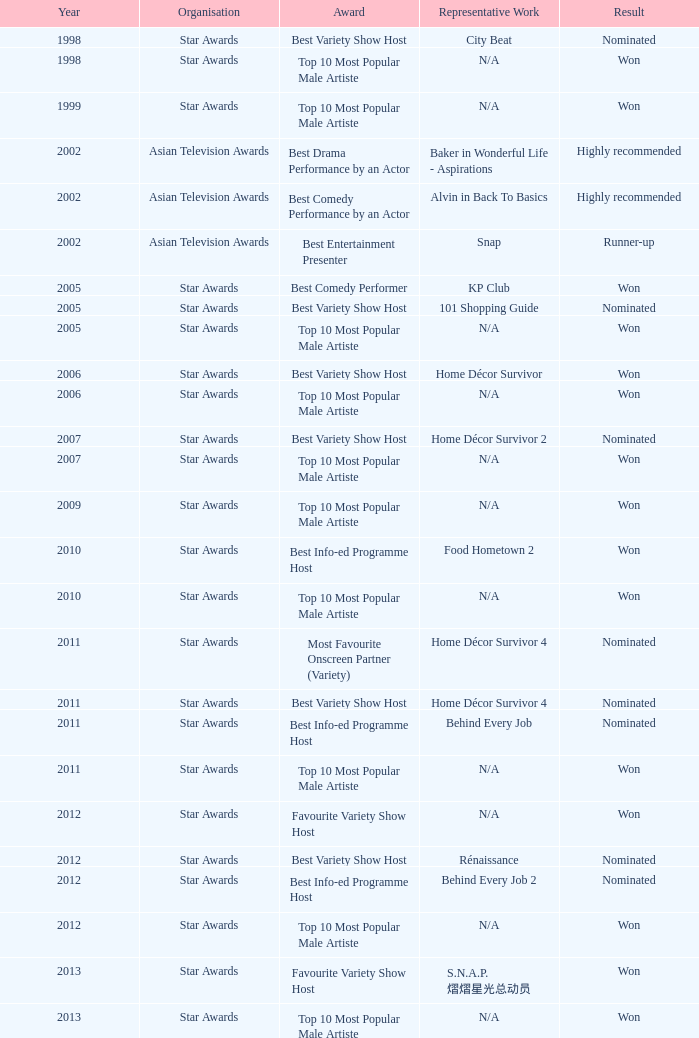What is the 1998 prize for the exemplary work of urban rhythm? Best Variety Show Host. 